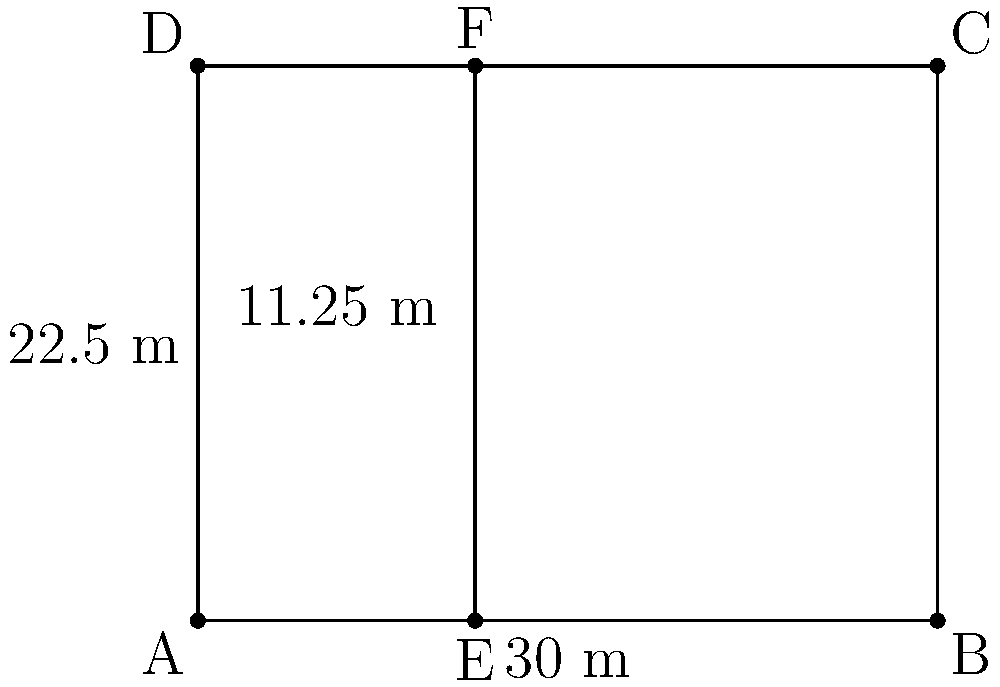A new affordable housing complex is being planned with a rectangular layout. The complex is divided into two sections: a larger area for family units and a smaller area for single-occupancy units. Given that the total length of the complex is 30 m and the width is 22.5 m, with the division between the two sections located 11.25 m from the left side, calculate the total area of the affordable housing complex in square meters. Let's approach this step-by-step:

1) First, we need to identify the shape of the entire complex. It's a rectangle.

2) The formula for the area of a rectangle is:
   $$ A = l \times w $$
   where $A$ is the area, $l$ is the length, and $w$ is the width.

3) We're given the following dimensions:
   - Length (l) = 30 m
   - Width (w) = 22.5 m

4) Now, let's plug these values into our formula:
   $$ A = 30 \text{ m} \times 22.5 \text{ m} $$

5) Performing the multiplication:
   $$ A = 675 \text{ m}^2 $$

6) Note: We don't need to calculate the areas of the two sections separately, as the total area is what we're asked for, and it's the same regardless of how the space is divided internally.

Therefore, the total area of the affordable housing complex is 675 square meters.
Answer: 675 m² 